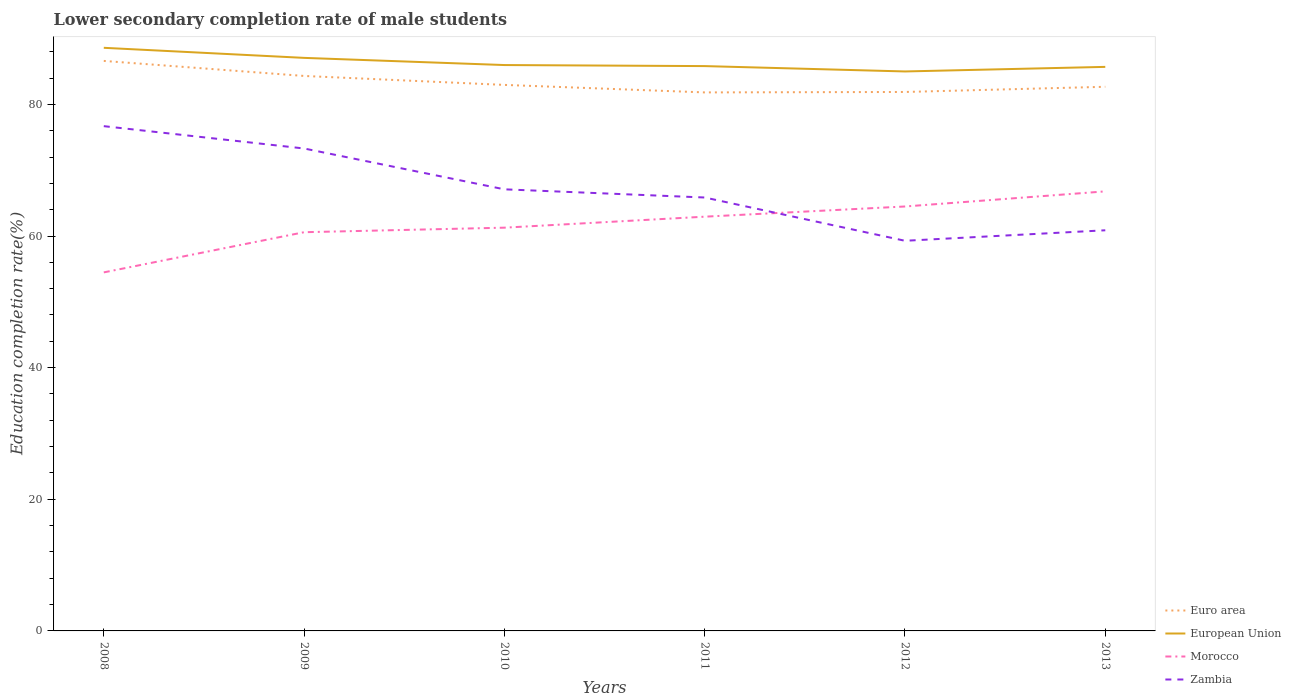How many different coloured lines are there?
Offer a terse response. 4. Across all years, what is the maximum lower secondary completion rate of male students in Morocco?
Your answer should be very brief. 54.47. In which year was the lower secondary completion rate of male students in Zambia maximum?
Provide a short and direct response. 2012. What is the total lower secondary completion rate of male students in Euro area in the graph?
Give a very brief answer. 0.29. What is the difference between the highest and the second highest lower secondary completion rate of male students in European Union?
Provide a succinct answer. 3.59. What is the difference between two consecutive major ticks on the Y-axis?
Give a very brief answer. 20. Does the graph contain any zero values?
Ensure brevity in your answer.  No. How many legend labels are there?
Offer a very short reply. 4. How are the legend labels stacked?
Your response must be concise. Vertical. What is the title of the graph?
Ensure brevity in your answer.  Lower secondary completion rate of male students. What is the label or title of the Y-axis?
Your answer should be compact. Education completion rate(%). What is the Education completion rate(%) in Euro area in 2008?
Your answer should be compact. 86.6. What is the Education completion rate(%) in European Union in 2008?
Offer a very short reply. 88.59. What is the Education completion rate(%) in Morocco in 2008?
Your response must be concise. 54.47. What is the Education completion rate(%) of Zambia in 2008?
Give a very brief answer. 76.69. What is the Education completion rate(%) in Euro area in 2009?
Provide a succinct answer. 84.32. What is the Education completion rate(%) of European Union in 2009?
Your answer should be compact. 87.06. What is the Education completion rate(%) in Morocco in 2009?
Provide a short and direct response. 60.58. What is the Education completion rate(%) of Zambia in 2009?
Offer a terse response. 73.3. What is the Education completion rate(%) of Euro area in 2010?
Your answer should be compact. 82.96. What is the Education completion rate(%) in European Union in 2010?
Ensure brevity in your answer.  85.97. What is the Education completion rate(%) in Morocco in 2010?
Provide a short and direct response. 61.27. What is the Education completion rate(%) in Zambia in 2010?
Make the answer very short. 67.09. What is the Education completion rate(%) in Euro area in 2011?
Make the answer very short. 81.82. What is the Education completion rate(%) in European Union in 2011?
Provide a succinct answer. 85.81. What is the Education completion rate(%) of Morocco in 2011?
Provide a succinct answer. 62.94. What is the Education completion rate(%) in Zambia in 2011?
Your answer should be compact. 65.85. What is the Education completion rate(%) of Euro area in 2012?
Offer a very short reply. 81.88. What is the Education completion rate(%) in European Union in 2012?
Make the answer very short. 85. What is the Education completion rate(%) of Morocco in 2012?
Provide a succinct answer. 64.48. What is the Education completion rate(%) of Zambia in 2012?
Provide a succinct answer. 59.28. What is the Education completion rate(%) of Euro area in 2013?
Your answer should be compact. 82.67. What is the Education completion rate(%) in European Union in 2013?
Your answer should be very brief. 85.7. What is the Education completion rate(%) in Morocco in 2013?
Your response must be concise. 66.78. What is the Education completion rate(%) in Zambia in 2013?
Ensure brevity in your answer.  60.87. Across all years, what is the maximum Education completion rate(%) in Euro area?
Keep it short and to the point. 86.6. Across all years, what is the maximum Education completion rate(%) in European Union?
Make the answer very short. 88.59. Across all years, what is the maximum Education completion rate(%) in Morocco?
Offer a terse response. 66.78. Across all years, what is the maximum Education completion rate(%) of Zambia?
Your answer should be very brief. 76.69. Across all years, what is the minimum Education completion rate(%) in Euro area?
Provide a succinct answer. 81.82. Across all years, what is the minimum Education completion rate(%) in European Union?
Offer a terse response. 85. Across all years, what is the minimum Education completion rate(%) of Morocco?
Ensure brevity in your answer.  54.47. Across all years, what is the minimum Education completion rate(%) of Zambia?
Your answer should be compact. 59.28. What is the total Education completion rate(%) of Euro area in the graph?
Your response must be concise. 500.24. What is the total Education completion rate(%) in European Union in the graph?
Your answer should be compact. 518.14. What is the total Education completion rate(%) in Morocco in the graph?
Your response must be concise. 370.52. What is the total Education completion rate(%) of Zambia in the graph?
Give a very brief answer. 403.07. What is the difference between the Education completion rate(%) in Euro area in 2008 and that in 2009?
Your response must be concise. 2.28. What is the difference between the Education completion rate(%) in European Union in 2008 and that in 2009?
Your answer should be very brief. 1.53. What is the difference between the Education completion rate(%) of Morocco in 2008 and that in 2009?
Keep it short and to the point. -6.1. What is the difference between the Education completion rate(%) of Zambia in 2008 and that in 2009?
Offer a very short reply. 3.39. What is the difference between the Education completion rate(%) in Euro area in 2008 and that in 2010?
Your response must be concise. 3.64. What is the difference between the Education completion rate(%) in European Union in 2008 and that in 2010?
Provide a succinct answer. 2.62. What is the difference between the Education completion rate(%) in Morocco in 2008 and that in 2010?
Provide a succinct answer. -6.79. What is the difference between the Education completion rate(%) in Zambia in 2008 and that in 2010?
Provide a short and direct response. 9.6. What is the difference between the Education completion rate(%) in Euro area in 2008 and that in 2011?
Ensure brevity in your answer.  4.78. What is the difference between the Education completion rate(%) of European Union in 2008 and that in 2011?
Your response must be concise. 2.78. What is the difference between the Education completion rate(%) in Morocco in 2008 and that in 2011?
Make the answer very short. -8.46. What is the difference between the Education completion rate(%) of Zambia in 2008 and that in 2011?
Your answer should be compact. 10.84. What is the difference between the Education completion rate(%) of Euro area in 2008 and that in 2012?
Offer a very short reply. 4.72. What is the difference between the Education completion rate(%) in European Union in 2008 and that in 2012?
Ensure brevity in your answer.  3.59. What is the difference between the Education completion rate(%) of Morocco in 2008 and that in 2012?
Ensure brevity in your answer.  -10.01. What is the difference between the Education completion rate(%) in Zambia in 2008 and that in 2012?
Offer a terse response. 17.41. What is the difference between the Education completion rate(%) in Euro area in 2008 and that in 2013?
Your response must be concise. 3.93. What is the difference between the Education completion rate(%) in European Union in 2008 and that in 2013?
Offer a terse response. 2.9. What is the difference between the Education completion rate(%) of Morocco in 2008 and that in 2013?
Offer a terse response. -12.31. What is the difference between the Education completion rate(%) in Zambia in 2008 and that in 2013?
Your response must be concise. 15.82. What is the difference between the Education completion rate(%) in Euro area in 2009 and that in 2010?
Your answer should be compact. 1.36. What is the difference between the Education completion rate(%) of European Union in 2009 and that in 2010?
Ensure brevity in your answer.  1.09. What is the difference between the Education completion rate(%) of Morocco in 2009 and that in 2010?
Keep it short and to the point. -0.69. What is the difference between the Education completion rate(%) in Zambia in 2009 and that in 2010?
Your response must be concise. 6.2. What is the difference between the Education completion rate(%) in Euro area in 2009 and that in 2011?
Your answer should be compact. 2.5. What is the difference between the Education completion rate(%) of European Union in 2009 and that in 2011?
Ensure brevity in your answer.  1.25. What is the difference between the Education completion rate(%) of Morocco in 2009 and that in 2011?
Offer a very short reply. -2.36. What is the difference between the Education completion rate(%) of Zambia in 2009 and that in 2011?
Provide a short and direct response. 7.45. What is the difference between the Education completion rate(%) in Euro area in 2009 and that in 2012?
Make the answer very short. 2.43. What is the difference between the Education completion rate(%) in European Union in 2009 and that in 2012?
Provide a succinct answer. 2.06. What is the difference between the Education completion rate(%) of Morocco in 2009 and that in 2012?
Your answer should be very brief. -3.91. What is the difference between the Education completion rate(%) of Zambia in 2009 and that in 2012?
Offer a terse response. 14.02. What is the difference between the Education completion rate(%) of Euro area in 2009 and that in 2013?
Make the answer very short. 1.65. What is the difference between the Education completion rate(%) in European Union in 2009 and that in 2013?
Provide a succinct answer. 1.37. What is the difference between the Education completion rate(%) in Morocco in 2009 and that in 2013?
Give a very brief answer. -6.21. What is the difference between the Education completion rate(%) in Zambia in 2009 and that in 2013?
Your answer should be very brief. 12.43. What is the difference between the Education completion rate(%) in Euro area in 2010 and that in 2011?
Your answer should be very brief. 1.14. What is the difference between the Education completion rate(%) in European Union in 2010 and that in 2011?
Provide a succinct answer. 0.16. What is the difference between the Education completion rate(%) of Morocco in 2010 and that in 2011?
Offer a very short reply. -1.67. What is the difference between the Education completion rate(%) in Zambia in 2010 and that in 2011?
Keep it short and to the point. 1.24. What is the difference between the Education completion rate(%) in Euro area in 2010 and that in 2012?
Provide a short and direct response. 1.07. What is the difference between the Education completion rate(%) in European Union in 2010 and that in 2012?
Provide a succinct answer. 0.97. What is the difference between the Education completion rate(%) in Morocco in 2010 and that in 2012?
Make the answer very short. -3.22. What is the difference between the Education completion rate(%) in Zambia in 2010 and that in 2012?
Your answer should be compact. 7.82. What is the difference between the Education completion rate(%) of Euro area in 2010 and that in 2013?
Make the answer very short. 0.29. What is the difference between the Education completion rate(%) in European Union in 2010 and that in 2013?
Provide a succinct answer. 0.28. What is the difference between the Education completion rate(%) of Morocco in 2010 and that in 2013?
Provide a succinct answer. -5.52. What is the difference between the Education completion rate(%) of Zambia in 2010 and that in 2013?
Provide a succinct answer. 6.22. What is the difference between the Education completion rate(%) in Euro area in 2011 and that in 2012?
Make the answer very short. -0.07. What is the difference between the Education completion rate(%) in European Union in 2011 and that in 2012?
Ensure brevity in your answer.  0.82. What is the difference between the Education completion rate(%) of Morocco in 2011 and that in 2012?
Your answer should be compact. -1.55. What is the difference between the Education completion rate(%) in Zambia in 2011 and that in 2012?
Your answer should be very brief. 6.57. What is the difference between the Education completion rate(%) in Euro area in 2011 and that in 2013?
Ensure brevity in your answer.  -0.85. What is the difference between the Education completion rate(%) of European Union in 2011 and that in 2013?
Ensure brevity in your answer.  0.12. What is the difference between the Education completion rate(%) of Morocco in 2011 and that in 2013?
Keep it short and to the point. -3.85. What is the difference between the Education completion rate(%) of Zambia in 2011 and that in 2013?
Ensure brevity in your answer.  4.98. What is the difference between the Education completion rate(%) in Euro area in 2012 and that in 2013?
Provide a succinct answer. -0.79. What is the difference between the Education completion rate(%) of European Union in 2012 and that in 2013?
Provide a short and direct response. -0.7. What is the difference between the Education completion rate(%) in Morocco in 2012 and that in 2013?
Your response must be concise. -2.3. What is the difference between the Education completion rate(%) in Zambia in 2012 and that in 2013?
Ensure brevity in your answer.  -1.59. What is the difference between the Education completion rate(%) in Euro area in 2008 and the Education completion rate(%) in European Union in 2009?
Ensure brevity in your answer.  -0.46. What is the difference between the Education completion rate(%) in Euro area in 2008 and the Education completion rate(%) in Morocco in 2009?
Ensure brevity in your answer.  26.02. What is the difference between the Education completion rate(%) in Euro area in 2008 and the Education completion rate(%) in Zambia in 2009?
Keep it short and to the point. 13.3. What is the difference between the Education completion rate(%) of European Union in 2008 and the Education completion rate(%) of Morocco in 2009?
Make the answer very short. 28.02. What is the difference between the Education completion rate(%) of European Union in 2008 and the Education completion rate(%) of Zambia in 2009?
Offer a very short reply. 15.3. What is the difference between the Education completion rate(%) in Morocco in 2008 and the Education completion rate(%) in Zambia in 2009?
Provide a short and direct response. -18.82. What is the difference between the Education completion rate(%) in Euro area in 2008 and the Education completion rate(%) in European Union in 2010?
Offer a terse response. 0.63. What is the difference between the Education completion rate(%) of Euro area in 2008 and the Education completion rate(%) of Morocco in 2010?
Your response must be concise. 25.33. What is the difference between the Education completion rate(%) in Euro area in 2008 and the Education completion rate(%) in Zambia in 2010?
Provide a short and direct response. 19.51. What is the difference between the Education completion rate(%) of European Union in 2008 and the Education completion rate(%) of Morocco in 2010?
Your answer should be compact. 27.33. What is the difference between the Education completion rate(%) of European Union in 2008 and the Education completion rate(%) of Zambia in 2010?
Keep it short and to the point. 21.5. What is the difference between the Education completion rate(%) in Morocco in 2008 and the Education completion rate(%) in Zambia in 2010?
Make the answer very short. -12.62. What is the difference between the Education completion rate(%) in Euro area in 2008 and the Education completion rate(%) in European Union in 2011?
Offer a very short reply. 0.79. What is the difference between the Education completion rate(%) of Euro area in 2008 and the Education completion rate(%) of Morocco in 2011?
Provide a short and direct response. 23.67. What is the difference between the Education completion rate(%) of Euro area in 2008 and the Education completion rate(%) of Zambia in 2011?
Ensure brevity in your answer.  20.75. What is the difference between the Education completion rate(%) in European Union in 2008 and the Education completion rate(%) in Morocco in 2011?
Keep it short and to the point. 25.66. What is the difference between the Education completion rate(%) of European Union in 2008 and the Education completion rate(%) of Zambia in 2011?
Your answer should be compact. 22.74. What is the difference between the Education completion rate(%) in Morocco in 2008 and the Education completion rate(%) in Zambia in 2011?
Give a very brief answer. -11.38. What is the difference between the Education completion rate(%) in Euro area in 2008 and the Education completion rate(%) in European Union in 2012?
Give a very brief answer. 1.6. What is the difference between the Education completion rate(%) of Euro area in 2008 and the Education completion rate(%) of Morocco in 2012?
Provide a succinct answer. 22.12. What is the difference between the Education completion rate(%) of Euro area in 2008 and the Education completion rate(%) of Zambia in 2012?
Your answer should be compact. 27.33. What is the difference between the Education completion rate(%) in European Union in 2008 and the Education completion rate(%) in Morocco in 2012?
Provide a succinct answer. 24.11. What is the difference between the Education completion rate(%) of European Union in 2008 and the Education completion rate(%) of Zambia in 2012?
Ensure brevity in your answer.  29.32. What is the difference between the Education completion rate(%) in Morocco in 2008 and the Education completion rate(%) in Zambia in 2012?
Offer a terse response. -4.8. What is the difference between the Education completion rate(%) of Euro area in 2008 and the Education completion rate(%) of European Union in 2013?
Ensure brevity in your answer.  0.91. What is the difference between the Education completion rate(%) in Euro area in 2008 and the Education completion rate(%) in Morocco in 2013?
Your answer should be compact. 19.82. What is the difference between the Education completion rate(%) of Euro area in 2008 and the Education completion rate(%) of Zambia in 2013?
Your answer should be very brief. 25.73. What is the difference between the Education completion rate(%) of European Union in 2008 and the Education completion rate(%) of Morocco in 2013?
Make the answer very short. 21.81. What is the difference between the Education completion rate(%) in European Union in 2008 and the Education completion rate(%) in Zambia in 2013?
Provide a short and direct response. 27.72. What is the difference between the Education completion rate(%) of Morocco in 2008 and the Education completion rate(%) of Zambia in 2013?
Provide a succinct answer. -6.4. What is the difference between the Education completion rate(%) of Euro area in 2009 and the Education completion rate(%) of European Union in 2010?
Offer a terse response. -1.66. What is the difference between the Education completion rate(%) in Euro area in 2009 and the Education completion rate(%) in Morocco in 2010?
Ensure brevity in your answer.  23.05. What is the difference between the Education completion rate(%) in Euro area in 2009 and the Education completion rate(%) in Zambia in 2010?
Your response must be concise. 17.23. What is the difference between the Education completion rate(%) in European Union in 2009 and the Education completion rate(%) in Morocco in 2010?
Provide a succinct answer. 25.8. What is the difference between the Education completion rate(%) of European Union in 2009 and the Education completion rate(%) of Zambia in 2010?
Give a very brief answer. 19.97. What is the difference between the Education completion rate(%) of Morocco in 2009 and the Education completion rate(%) of Zambia in 2010?
Your response must be concise. -6.52. What is the difference between the Education completion rate(%) in Euro area in 2009 and the Education completion rate(%) in European Union in 2011?
Give a very brief answer. -1.5. What is the difference between the Education completion rate(%) of Euro area in 2009 and the Education completion rate(%) of Morocco in 2011?
Provide a short and direct response. 21.38. What is the difference between the Education completion rate(%) of Euro area in 2009 and the Education completion rate(%) of Zambia in 2011?
Ensure brevity in your answer.  18.47. What is the difference between the Education completion rate(%) in European Union in 2009 and the Education completion rate(%) in Morocco in 2011?
Your answer should be compact. 24.13. What is the difference between the Education completion rate(%) of European Union in 2009 and the Education completion rate(%) of Zambia in 2011?
Provide a succinct answer. 21.21. What is the difference between the Education completion rate(%) of Morocco in 2009 and the Education completion rate(%) of Zambia in 2011?
Give a very brief answer. -5.27. What is the difference between the Education completion rate(%) of Euro area in 2009 and the Education completion rate(%) of European Union in 2012?
Keep it short and to the point. -0.68. What is the difference between the Education completion rate(%) of Euro area in 2009 and the Education completion rate(%) of Morocco in 2012?
Your response must be concise. 19.83. What is the difference between the Education completion rate(%) in Euro area in 2009 and the Education completion rate(%) in Zambia in 2012?
Provide a succinct answer. 25.04. What is the difference between the Education completion rate(%) in European Union in 2009 and the Education completion rate(%) in Morocco in 2012?
Make the answer very short. 22.58. What is the difference between the Education completion rate(%) of European Union in 2009 and the Education completion rate(%) of Zambia in 2012?
Give a very brief answer. 27.79. What is the difference between the Education completion rate(%) of Morocco in 2009 and the Education completion rate(%) of Zambia in 2012?
Provide a succinct answer. 1.3. What is the difference between the Education completion rate(%) in Euro area in 2009 and the Education completion rate(%) in European Union in 2013?
Provide a succinct answer. -1.38. What is the difference between the Education completion rate(%) of Euro area in 2009 and the Education completion rate(%) of Morocco in 2013?
Ensure brevity in your answer.  17.54. What is the difference between the Education completion rate(%) of Euro area in 2009 and the Education completion rate(%) of Zambia in 2013?
Provide a succinct answer. 23.45. What is the difference between the Education completion rate(%) of European Union in 2009 and the Education completion rate(%) of Morocco in 2013?
Your response must be concise. 20.28. What is the difference between the Education completion rate(%) of European Union in 2009 and the Education completion rate(%) of Zambia in 2013?
Provide a succinct answer. 26.19. What is the difference between the Education completion rate(%) in Morocco in 2009 and the Education completion rate(%) in Zambia in 2013?
Offer a terse response. -0.29. What is the difference between the Education completion rate(%) of Euro area in 2010 and the Education completion rate(%) of European Union in 2011?
Offer a very short reply. -2.86. What is the difference between the Education completion rate(%) in Euro area in 2010 and the Education completion rate(%) in Morocco in 2011?
Provide a short and direct response. 20.02. What is the difference between the Education completion rate(%) of Euro area in 2010 and the Education completion rate(%) of Zambia in 2011?
Your answer should be compact. 17.11. What is the difference between the Education completion rate(%) in European Union in 2010 and the Education completion rate(%) in Morocco in 2011?
Your answer should be compact. 23.04. What is the difference between the Education completion rate(%) in European Union in 2010 and the Education completion rate(%) in Zambia in 2011?
Ensure brevity in your answer.  20.12. What is the difference between the Education completion rate(%) of Morocco in 2010 and the Education completion rate(%) of Zambia in 2011?
Offer a very short reply. -4.58. What is the difference between the Education completion rate(%) in Euro area in 2010 and the Education completion rate(%) in European Union in 2012?
Keep it short and to the point. -2.04. What is the difference between the Education completion rate(%) of Euro area in 2010 and the Education completion rate(%) of Morocco in 2012?
Your answer should be compact. 18.47. What is the difference between the Education completion rate(%) of Euro area in 2010 and the Education completion rate(%) of Zambia in 2012?
Provide a succinct answer. 23.68. What is the difference between the Education completion rate(%) of European Union in 2010 and the Education completion rate(%) of Morocco in 2012?
Give a very brief answer. 21.49. What is the difference between the Education completion rate(%) in European Union in 2010 and the Education completion rate(%) in Zambia in 2012?
Offer a very short reply. 26.7. What is the difference between the Education completion rate(%) of Morocco in 2010 and the Education completion rate(%) of Zambia in 2012?
Provide a short and direct response. 1.99. What is the difference between the Education completion rate(%) in Euro area in 2010 and the Education completion rate(%) in European Union in 2013?
Your response must be concise. -2.74. What is the difference between the Education completion rate(%) in Euro area in 2010 and the Education completion rate(%) in Morocco in 2013?
Provide a succinct answer. 16.17. What is the difference between the Education completion rate(%) in Euro area in 2010 and the Education completion rate(%) in Zambia in 2013?
Offer a terse response. 22.09. What is the difference between the Education completion rate(%) in European Union in 2010 and the Education completion rate(%) in Morocco in 2013?
Make the answer very short. 19.19. What is the difference between the Education completion rate(%) of European Union in 2010 and the Education completion rate(%) of Zambia in 2013?
Make the answer very short. 25.1. What is the difference between the Education completion rate(%) in Morocco in 2010 and the Education completion rate(%) in Zambia in 2013?
Offer a terse response. 0.4. What is the difference between the Education completion rate(%) of Euro area in 2011 and the Education completion rate(%) of European Union in 2012?
Ensure brevity in your answer.  -3.18. What is the difference between the Education completion rate(%) of Euro area in 2011 and the Education completion rate(%) of Morocco in 2012?
Your response must be concise. 17.33. What is the difference between the Education completion rate(%) in Euro area in 2011 and the Education completion rate(%) in Zambia in 2012?
Give a very brief answer. 22.54. What is the difference between the Education completion rate(%) in European Union in 2011 and the Education completion rate(%) in Morocco in 2012?
Offer a terse response. 21.33. What is the difference between the Education completion rate(%) of European Union in 2011 and the Education completion rate(%) of Zambia in 2012?
Offer a terse response. 26.54. What is the difference between the Education completion rate(%) in Morocco in 2011 and the Education completion rate(%) in Zambia in 2012?
Provide a short and direct response. 3.66. What is the difference between the Education completion rate(%) in Euro area in 2011 and the Education completion rate(%) in European Union in 2013?
Offer a terse response. -3.88. What is the difference between the Education completion rate(%) of Euro area in 2011 and the Education completion rate(%) of Morocco in 2013?
Give a very brief answer. 15.03. What is the difference between the Education completion rate(%) of Euro area in 2011 and the Education completion rate(%) of Zambia in 2013?
Provide a short and direct response. 20.95. What is the difference between the Education completion rate(%) of European Union in 2011 and the Education completion rate(%) of Morocco in 2013?
Ensure brevity in your answer.  19.03. What is the difference between the Education completion rate(%) of European Union in 2011 and the Education completion rate(%) of Zambia in 2013?
Your answer should be compact. 24.95. What is the difference between the Education completion rate(%) in Morocco in 2011 and the Education completion rate(%) in Zambia in 2013?
Your response must be concise. 2.07. What is the difference between the Education completion rate(%) of Euro area in 2012 and the Education completion rate(%) of European Union in 2013?
Your answer should be compact. -3.81. What is the difference between the Education completion rate(%) in Euro area in 2012 and the Education completion rate(%) in Morocco in 2013?
Keep it short and to the point. 15.1. What is the difference between the Education completion rate(%) of Euro area in 2012 and the Education completion rate(%) of Zambia in 2013?
Give a very brief answer. 21.01. What is the difference between the Education completion rate(%) of European Union in 2012 and the Education completion rate(%) of Morocco in 2013?
Offer a very short reply. 18.22. What is the difference between the Education completion rate(%) in European Union in 2012 and the Education completion rate(%) in Zambia in 2013?
Provide a succinct answer. 24.13. What is the difference between the Education completion rate(%) of Morocco in 2012 and the Education completion rate(%) of Zambia in 2013?
Your answer should be very brief. 3.61. What is the average Education completion rate(%) in Euro area per year?
Your response must be concise. 83.37. What is the average Education completion rate(%) of European Union per year?
Ensure brevity in your answer.  86.36. What is the average Education completion rate(%) of Morocco per year?
Provide a succinct answer. 61.75. What is the average Education completion rate(%) in Zambia per year?
Your answer should be very brief. 67.18. In the year 2008, what is the difference between the Education completion rate(%) in Euro area and Education completion rate(%) in European Union?
Provide a short and direct response. -1.99. In the year 2008, what is the difference between the Education completion rate(%) in Euro area and Education completion rate(%) in Morocco?
Offer a terse response. 32.13. In the year 2008, what is the difference between the Education completion rate(%) of Euro area and Education completion rate(%) of Zambia?
Make the answer very short. 9.91. In the year 2008, what is the difference between the Education completion rate(%) in European Union and Education completion rate(%) in Morocco?
Give a very brief answer. 34.12. In the year 2008, what is the difference between the Education completion rate(%) in European Union and Education completion rate(%) in Zambia?
Provide a short and direct response. 11.9. In the year 2008, what is the difference between the Education completion rate(%) in Morocco and Education completion rate(%) in Zambia?
Provide a short and direct response. -22.22. In the year 2009, what is the difference between the Education completion rate(%) of Euro area and Education completion rate(%) of European Union?
Give a very brief answer. -2.75. In the year 2009, what is the difference between the Education completion rate(%) in Euro area and Education completion rate(%) in Morocco?
Provide a short and direct response. 23.74. In the year 2009, what is the difference between the Education completion rate(%) in Euro area and Education completion rate(%) in Zambia?
Make the answer very short. 11.02. In the year 2009, what is the difference between the Education completion rate(%) of European Union and Education completion rate(%) of Morocco?
Provide a succinct answer. 26.49. In the year 2009, what is the difference between the Education completion rate(%) in European Union and Education completion rate(%) in Zambia?
Offer a terse response. 13.77. In the year 2009, what is the difference between the Education completion rate(%) in Morocco and Education completion rate(%) in Zambia?
Your answer should be compact. -12.72. In the year 2010, what is the difference between the Education completion rate(%) in Euro area and Education completion rate(%) in European Union?
Offer a very short reply. -3.02. In the year 2010, what is the difference between the Education completion rate(%) in Euro area and Education completion rate(%) in Morocco?
Keep it short and to the point. 21.69. In the year 2010, what is the difference between the Education completion rate(%) of Euro area and Education completion rate(%) of Zambia?
Offer a terse response. 15.87. In the year 2010, what is the difference between the Education completion rate(%) in European Union and Education completion rate(%) in Morocco?
Keep it short and to the point. 24.71. In the year 2010, what is the difference between the Education completion rate(%) of European Union and Education completion rate(%) of Zambia?
Offer a terse response. 18.88. In the year 2010, what is the difference between the Education completion rate(%) of Morocco and Education completion rate(%) of Zambia?
Ensure brevity in your answer.  -5.83. In the year 2011, what is the difference between the Education completion rate(%) of Euro area and Education completion rate(%) of European Union?
Keep it short and to the point. -4. In the year 2011, what is the difference between the Education completion rate(%) in Euro area and Education completion rate(%) in Morocco?
Make the answer very short. 18.88. In the year 2011, what is the difference between the Education completion rate(%) in Euro area and Education completion rate(%) in Zambia?
Offer a terse response. 15.97. In the year 2011, what is the difference between the Education completion rate(%) in European Union and Education completion rate(%) in Morocco?
Your answer should be very brief. 22.88. In the year 2011, what is the difference between the Education completion rate(%) in European Union and Education completion rate(%) in Zambia?
Your response must be concise. 19.97. In the year 2011, what is the difference between the Education completion rate(%) in Morocco and Education completion rate(%) in Zambia?
Your answer should be very brief. -2.91. In the year 2012, what is the difference between the Education completion rate(%) in Euro area and Education completion rate(%) in European Union?
Give a very brief answer. -3.12. In the year 2012, what is the difference between the Education completion rate(%) in Euro area and Education completion rate(%) in Morocco?
Provide a succinct answer. 17.4. In the year 2012, what is the difference between the Education completion rate(%) of Euro area and Education completion rate(%) of Zambia?
Ensure brevity in your answer.  22.61. In the year 2012, what is the difference between the Education completion rate(%) of European Union and Education completion rate(%) of Morocco?
Provide a short and direct response. 20.52. In the year 2012, what is the difference between the Education completion rate(%) in European Union and Education completion rate(%) in Zambia?
Your response must be concise. 25.72. In the year 2012, what is the difference between the Education completion rate(%) in Morocco and Education completion rate(%) in Zambia?
Provide a short and direct response. 5.21. In the year 2013, what is the difference between the Education completion rate(%) of Euro area and Education completion rate(%) of European Union?
Provide a short and direct response. -3.02. In the year 2013, what is the difference between the Education completion rate(%) in Euro area and Education completion rate(%) in Morocco?
Your answer should be compact. 15.89. In the year 2013, what is the difference between the Education completion rate(%) in Euro area and Education completion rate(%) in Zambia?
Your answer should be compact. 21.8. In the year 2013, what is the difference between the Education completion rate(%) in European Union and Education completion rate(%) in Morocco?
Your response must be concise. 18.91. In the year 2013, what is the difference between the Education completion rate(%) of European Union and Education completion rate(%) of Zambia?
Provide a succinct answer. 24.83. In the year 2013, what is the difference between the Education completion rate(%) in Morocco and Education completion rate(%) in Zambia?
Your answer should be very brief. 5.91. What is the ratio of the Education completion rate(%) in Euro area in 2008 to that in 2009?
Give a very brief answer. 1.03. What is the ratio of the Education completion rate(%) in European Union in 2008 to that in 2009?
Your response must be concise. 1.02. What is the ratio of the Education completion rate(%) of Morocco in 2008 to that in 2009?
Keep it short and to the point. 0.9. What is the ratio of the Education completion rate(%) in Zambia in 2008 to that in 2009?
Your response must be concise. 1.05. What is the ratio of the Education completion rate(%) of Euro area in 2008 to that in 2010?
Provide a succinct answer. 1.04. What is the ratio of the Education completion rate(%) of European Union in 2008 to that in 2010?
Provide a succinct answer. 1.03. What is the ratio of the Education completion rate(%) in Morocco in 2008 to that in 2010?
Offer a very short reply. 0.89. What is the ratio of the Education completion rate(%) in Zambia in 2008 to that in 2010?
Provide a short and direct response. 1.14. What is the ratio of the Education completion rate(%) in Euro area in 2008 to that in 2011?
Provide a succinct answer. 1.06. What is the ratio of the Education completion rate(%) of European Union in 2008 to that in 2011?
Provide a succinct answer. 1.03. What is the ratio of the Education completion rate(%) of Morocco in 2008 to that in 2011?
Offer a very short reply. 0.87. What is the ratio of the Education completion rate(%) of Zambia in 2008 to that in 2011?
Provide a succinct answer. 1.16. What is the ratio of the Education completion rate(%) of Euro area in 2008 to that in 2012?
Keep it short and to the point. 1.06. What is the ratio of the Education completion rate(%) in European Union in 2008 to that in 2012?
Ensure brevity in your answer.  1.04. What is the ratio of the Education completion rate(%) in Morocco in 2008 to that in 2012?
Your response must be concise. 0.84. What is the ratio of the Education completion rate(%) of Zambia in 2008 to that in 2012?
Provide a short and direct response. 1.29. What is the ratio of the Education completion rate(%) of Euro area in 2008 to that in 2013?
Your answer should be compact. 1.05. What is the ratio of the Education completion rate(%) of European Union in 2008 to that in 2013?
Your response must be concise. 1.03. What is the ratio of the Education completion rate(%) of Morocco in 2008 to that in 2013?
Provide a short and direct response. 0.82. What is the ratio of the Education completion rate(%) in Zambia in 2008 to that in 2013?
Provide a succinct answer. 1.26. What is the ratio of the Education completion rate(%) of Euro area in 2009 to that in 2010?
Your response must be concise. 1.02. What is the ratio of the Education completion rate(%) of European Union in 2009 to that in 2010?
Your answer should be compact. 1.01. What is the ratio of the Education completion rate(%) in Morocco in 2009 to that in 2010?
Your response must be concise. 0.99. What is the ratio of the Education completion rate(%) of Zambia in 2009 to that in 2010?
Offer a very short reply. 1.09. What is the ratio of the Education completion rate(%) of Euro area in 2009 to that in 2011?
Your response must be concise. 1.03. What is the ratio of the Education completion rate(%) of European Union in 2009 to that in 2011?
Your response must be concise. 1.01. What is the ratio of the Education completion rate(%) in Morocco in 2009 to that in 2011?
Offer a very short reply. 0.96. What is the ratio of the Education completion rate(%) of Zambia in 2009 to that in 2011?
Your answer should be compact. 1.11. What is the ratio of the Education completion rate(%) of Euro area in 2009 to that in 2012?
Offer a terse response. 1.03. What is the ratio of the Education completion rate(%) of European Union in 2009 to that in 2012?
Keep it short and to the point. 1.02. What is the ratio of the Education completion rate(%) in Morocco in 2009 to that in 2012?
Offer a very short reply. 0.94. What is the ratio of the Education completion rate(%) of Zambia in 2009 to that in 2012?
Keep it short and to the point. 1.24. What is the ratio of the Education completion rate(%) in Euro area in 2009 to that in 2013?
Provide a short and direct response. 1.02. What is the ratio of the Education completion rate(%) in Morocco in 2009 to that in 2013?
Offer a very short reply. 0.91. What is the ratio of the Education completion rate(%) in Zambia in 2009 to that in 2013?
Your answer should be compact. 1.2. What is the ratio of the Education completion rate(%) of Euro area in 2010 to that in 2011?
Provide a succinct answer. 1.01. What is the ratio of the Education completion rate(%) of European Union in 2010 to that in 2011?
Your answer should be compact. 1. What is the ratio of the Education completion rate(%) in Morocco in 2010 to that in 2011?
Provide a short and direct response. 0.97. What is the ratio of the Education completion rate(%) in Zambia in 2010 to that in 2011?
Offer a very short reply. 1.02. What is the ratio of the Education completion rate(%) in Euro area in 2010 to that in 2012?
Make the answer very short. 1.01. What is the ratio of the Education completion rate(%) of European Union in 2010 to that in 2012?
Your answer should be compact. 1.01. What is the ratio of the Education completion rate(%) of Morocco in 2010 to that in 2012?
Your response must be concise. 0.95. What is the ratio of the Education completion rate(%) in Zambia in 2010 to that in 2012?
Provide a short and direct response. 1.13. What is the ratio of the Education completion rate(%) in Morocco in 2010 to that in 2013?
Keep it short and to the point. 0.92. What is the ratio of the Education completion rate(%) in Zambia in 2010 to that in 2013?
Your response must be concise. 1.1. What is the ratio of the Education completion rate(%) of Euro area in 2011 to that in 2012?
Make the answer very short. 1. What is the ratio of the Education completion rate(%) of European Union in 2011 to that in 2012?
Offer a terse response. 1.01. What is the ratio of the Education completion rate(%) in Morocco in 2011 to that in 2012?
Keep it short and to the point. 0.98. What is the ratio of the Education completion rate(%) in Zambia in 2011 to that in 2012?
Give a very brief answer. 1.11. What is the ratio of the Education completion rate(%) of European Union in 2011 to that in 2013?
Ensure brevity in your answer.  1. What is the ratio of the Education completion rate(%) in Morocco in 2011 to that in 2013?
Give a very brief answer. 0.94. What is the ratio of the Education completion rate(%) of Zambia in 2011 to that in 2013?
Your response must be concise. 1.08. What is the ratio of the Education completion rate(%) in European Union in 2012 to that in 2013?
Your response must be concise. 0.99. What is the ratio of the Education completion rate(%) in Morocco in 2012 to that in 2013?
Provide a succinct answer. 0.97. What is the ratio of the Education completion rate(%) of Zambia in 2012 to that in 2013?
Provide a succinct answer. 0.97. What is the difference between the highest and the second highest Education completion rate(%) of Euro area?
Ensure brevity in your answer.  2.28. What is the difference between the highest and the second highest Education completion rate(%) of European Union?
Provide a short and direct response. 1.53. What is the difference between the highest and the second highest Education completion rate(%) in Morocco?
Make the answer very short. 2.3. What is the difference between the highest and the second highest Education completion rate(%) in Zambia?
Give a very brief answer. 3.39. What is the difference between the highest and the lowest Education completion rate(%) of Euro area?
Provide a short and direct response. 4.78. What is the difference between the highest and the lowest Education completion rate(%) in European Union?
Provide a succinct answer. 3.59. What is the difference between the highest and the lowest Education completion rate(%) of Morocco?
Keep it short and to the point. 12.31. What is the difference between the highest and the lowest Education completion rate(%) of Zambia?
Make the answer very short. 17.41. 